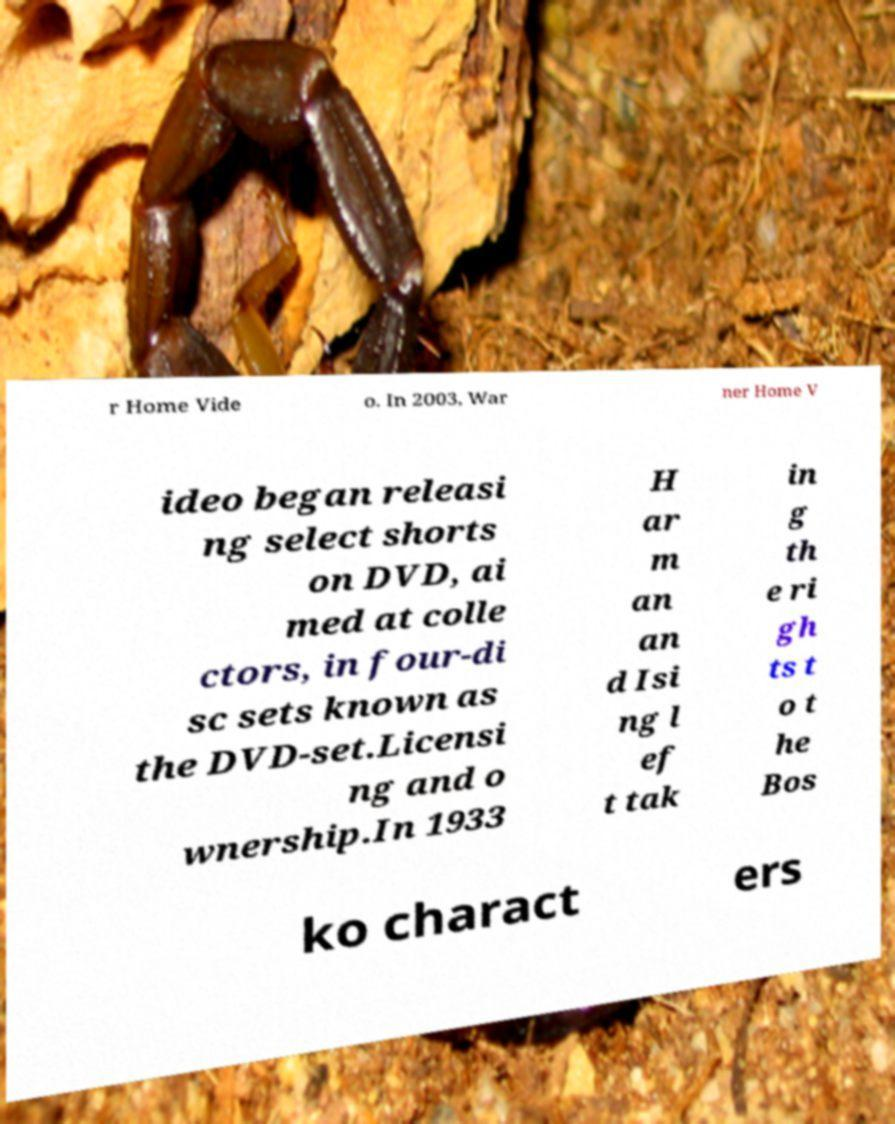Could you extract and type out the text from this image? r Home Vide o. In 2003, War ner Home V ideo began releasi ng select shorts on DVD, ai med at colle ctors, in four-di sc sets known as the DVD-set.Licensi ng and o wnership.In 1933 H ar m an an d Isi ng l ef t tak in g th e ri gh ts t o t he Bos ko charact ers 